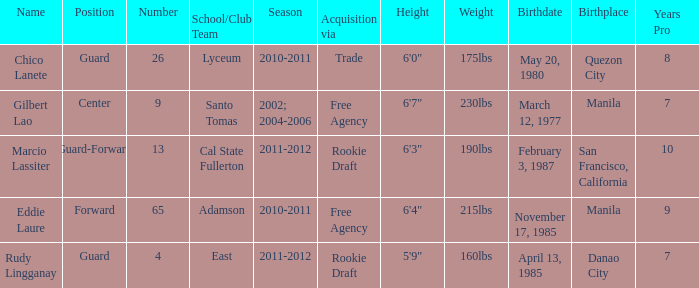What season had an acquisition of free agency, and was higher than 9? 2010-2011. 